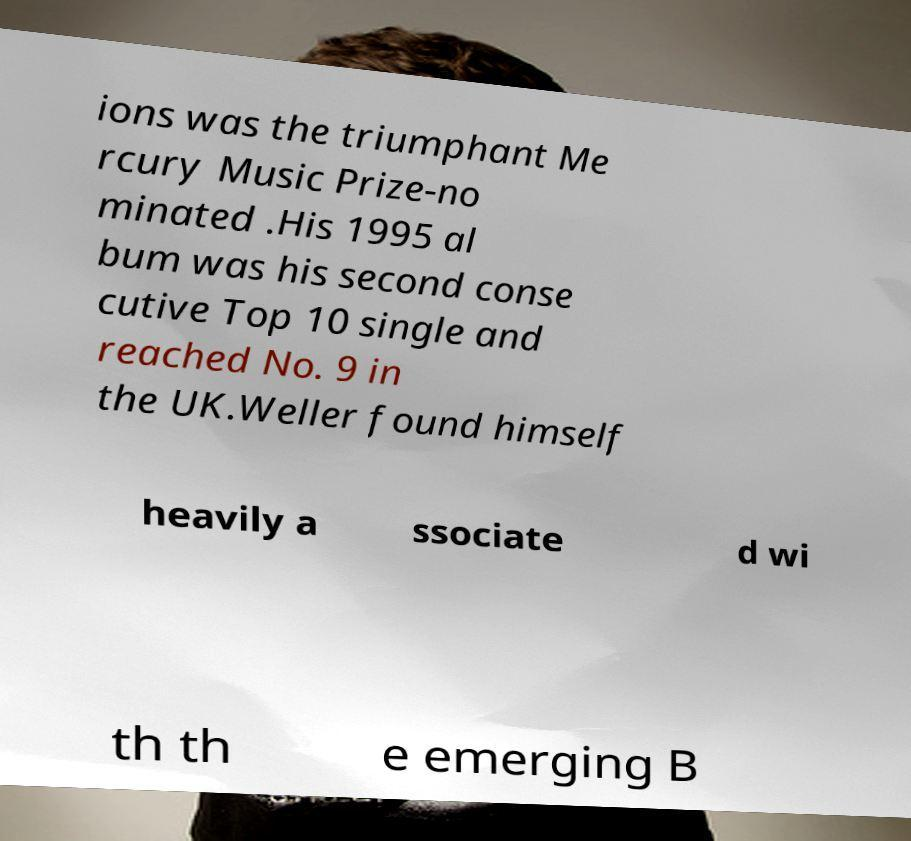What messages or text are displayed in this image? I need them in a readable, typed format. ions was the triumphant Me rcury Music Prize-no minated .His 1995 al bum was his second conse cutive Top 10 single and reached No. 9 in the UK.Weller found himself heavily a ssociate d wi th th e emerging B 